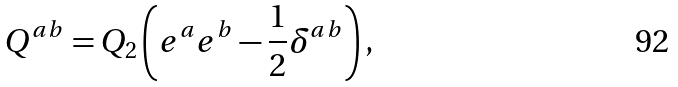Convert formula to latex. <formula><loc_0><loc_0><loc_500><loc_500>Q ^ { a b } = Q _ { 2 } \left ( e ^ { a } e ^ { b } - \frac { 1 } { 2 } \delta ^ { a b } \right ) ,</formula> 